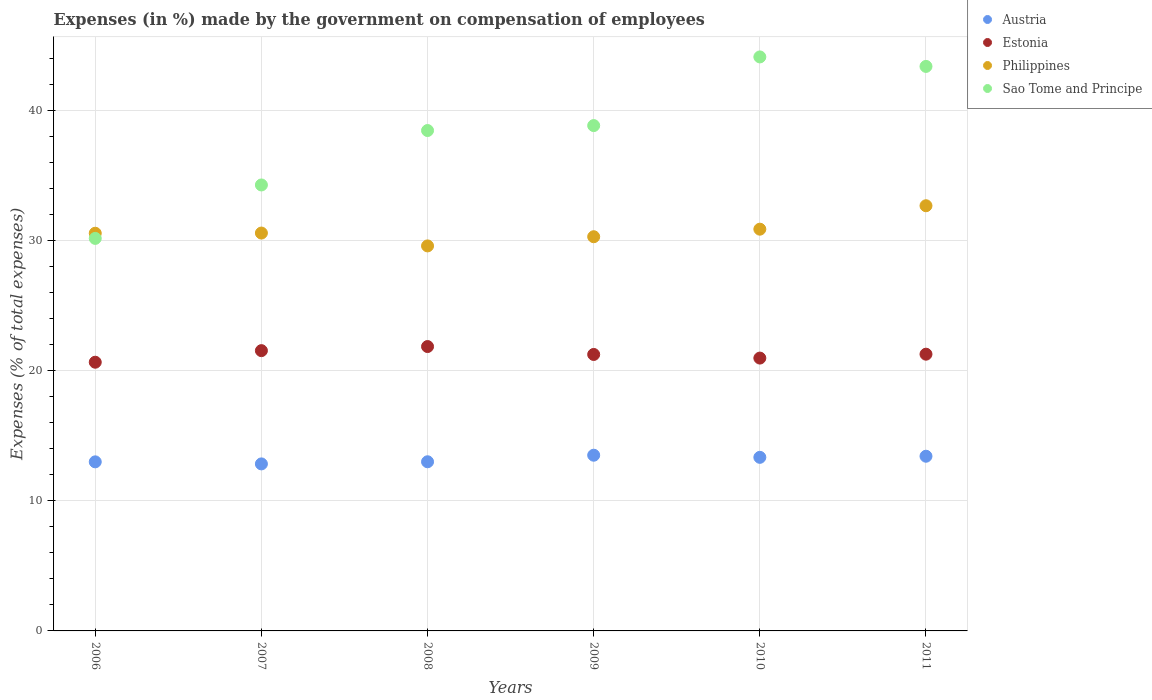How many different coloured dotlines are there?
Offer a terse response. 4. What is the percentage of expenses made by the government on compensation of employees in Philippines in 2006?
Give a very brief answer. 30.58. Across all years, what is the maximum percentage of expenses made by the government on compensation of employees in Austria?
Your answer should be very brief. 13.51. Across all years, what is the minimum percentage of expenses made by the government on compensation of employees in Philippines?
Offer a terse response. 29.6. In which year was the percentage of expenses made by the government on compensation of employees in Estonia minimum?
Your answer should be very brief. 2006. What is the total percentage of expenses made by the government on compensation of employees in Austria in the graph?
Your answer should be very brief. 79.14. What is the difference between the percentage of expenses made by the government on compensation of employees in Sao Tome and Principe in 2006 and that in 2009?
Your response must be concise. -8.67. What is the difference between the percentage of expenses made by the government on compensation of employees in Sao Tome and Principe in 2011 and the percentage of expenses made by the government on compensation of employees in Philippines in 2009?
Keep it short and to the point. 13.1. What is the average percentage of expenses made by the government on compensation of employees in Estonia per year?
Give a very brief answer. 21.27. In the year 2007, what is the difference between the percentage of expenses made by the government on compensation of employees in Austria and percentage of expenses made by the government on compensation of employees in Sao Tome and Principe?
Offer a terse response. -21.45. What is the ratio of the percentage of expenses made by the government on compensation of employees in Sao Tome and Principe in 2007 to that in 2011?
Your answer should be very brief. 0.79. Is the difference between the percentage of expenses made by the government on compensation of employees in Austria in 2009 and 2011 greater than the difference between the percentage of expenses made by the government on compensation of employees in Sao Tome and Principe in 2009 and 2011?
Your response must be concise. Yes. What is the difference between the highest and the second highest percentage of expenses made by the government on compensation of employees in Estonia?
Keep it short and to the point. 0.32. What is the difference between the highest and the lowest percentage of expenses made by the government on compensation of employees in Austria?
Make the answer very short. 0.67. In how many years, is the percentage of expenses made by the government on compensation of employees in Sao Tome and Principe greater than the average percentage of expenses made by the government on compensation of employees in Sao Tome and Principe taken over all years?
Your response must be concise. 4. Is it the case that in every year, the sum of the percentage of expenses made by the government on compensation of employees in Austria and percentage of expenses made by the government on compensation of employees in Philippines  is greater than the sum of percentage of expenses made by the government on compensation of employees in Sao Tome and Principe and percentage of expenses made by the government on compensation of employees in Estonia?
Provide a succinct answer. No. Does the percentage of expenses made by the government on compensation of employees in Sao Tome and Principe monotonically increase over the years?
Provide a short and direct response. No. Is the percentage of expenses made by the government on compensation of employees in Sao Tome and Principe strictly greater than the percentage of expenses made by the government on compensation of employees in Austria over the years?
Your response must be concise. Yes. How many dotlines are there?
Give a very brief answer. 4. How many years are there in the graph?
Provide a short and direct response. 6. Does the graph contain any zero values?
Ensure brevity in your answer.  No. How many legend labels are there?
Give a very brief answer. 4. How are the legend labels stacked?
Give a very brief answer. Vertical. What is the title of the graph?
Your answer should be compact. Expenses (in %) made by the government on compensation of employees. What is the label or title of the X-axis?
Ensure brevity in your answer.  Years. What is the label or title of the Y-axis?
Your answer should be compact. Expenses (% of total expenses). What is the Expenses (% of total expenses) in Austria in 2006?
Give a very brief answer. 13. What is the Expenses (% of total expenses) of Estonia in 2006?
Provide a succinct answer. 20.66. What is the Expenses (% of total expenses) of Philippines in 2006?
Offer a terse response. 30.58. What is the Expenses (% of total expenses) in Sao Tome and Principe in 2006?
Offer a terse response. 30.18. What is the Expenses (% of total expenses) of Austria in 2007?
Ensure brevity in your answer.  12.84. What is the Expenses (% of total expenses) in Estonia in 2007?
Provide a short and direct response. 21.55. What is the Expenses (% of total expenses) of Philippines in 2007?
Keep it short and to the point. 30.59. What is the Expenses (% of total expenses) of Sao Tome and Principe in 2007?
Offer a very short reply. 34.29. What is the Expenses (% of total expenses) of Austria in 2008?
Offer a terse response. 13.01. What is the Expenses (% of total expenses) of Estonia in 2008?
Provide a short and direct response. 21.87. What is the Expenses (% of total expenses) in Philippines in 2008?
Ensure brevity in your answer.  29.6. What is the Expenses (% of total expenses) of Sao Tome and Principe in 2008?
Make the answer very short. 38.48. What is the Expenses (% of total expenses) of Austria in 2009?
Your response must be concise. 13.51. What is the Expenses (% of total expenses) in Estonia in 2009?
Provide a short and direct response. 21.26. What is the Expenses (% of total expenses) in Philippines in 2009?
Ensure brevity in your answer.  30.31. What is the Expenses (% of total expenses) in Sao Tome and Principe in 2009?
Give a very brief answer. 38.86. What is the Expenses (% of total expenses) of Austria in 2010?
Ensure brevity in your answer.  13.35. What is the Expenses (% of total expenses) in Estonia in 2010?
Provide a short and direct response. 20.98. What is the Expenses (% of total expenses) of Philippines in 2010?
Your answer should be very brief. 30.89. What is the Expenses (% of total expenses) in Sao Tome and Principe in 2010?
Provide a succinct answer. 44.14. What is the Expenses (% of total expenses) of Austria in 2011?
Ensure brevity in your answer.  13.43. What is the Expenses (% of total expenses) of Estonia in 2011?
Keep it short and to the point. 21.28. What is the Expenses (% of total expenses) in Philippines in 2011?
Keep it short and to the point. 32.69. What is the Expenses (% of total expenses) of Sao Tome and Principe in 2011?
Give a very brief answer. 43.41. Across all years, what is the maximum Expenses (% of total expenses) in Austria?
Provide a succinct answer. 13.51. Across all years, what is the maximum Expenses (% of total expenses) of Estonia?
Offer a terse response. 21.87. Across all years, what is the maximum Expenses (% of total expenses) of Philippines?
Offer a terse response. 32.69. Across all years, what is the maximum Expenses (% of total expenses) of Sao Tome and Principe?
Offer a very short reply. 44.14. Across all years, what is the minimum Expenses (% of total expenses) in Austria?
Provide a short and direct response. 12.84. Across all years, what is the minimum Expenses (% of total expenses) in Estonia?
Give a very brief answer. 20.66. Across all years, what is the minimum Expenses (% of total expenses) in Philippines?
Ensure brevity in your answer.  29.6. Across all years, what is the minimum Expenses (% of total expenses) in Sao Tome and Principe?
Offer a terse response. 30.18. What is the total Expenses (% of total expenses) in Austria in the graph?
Keep it short and to the point. 79.14. What is the total Expenses (% of total expenses) in Estonia in the graph?
Your answer should be very brief. 127.59. What is the total Expenses (% of total expenses) in Philippines in the graph?
Your response must be concise. 184.67. What is the total Expenses (% of total expenses) in Sao Tome and Principe in the graph?
Provide a short and direct response. 229.35. What is the difference between the Expenses (% of total expenses) in Austria in 2006 and that in 2007?
Your answer should be very brief. 0.16. What is the difference between the Expenses (% of total expenses) of Estonia in 2006 and that in 2007?
Your response must be concise. -0.89. What is the difference between the Expenses (% of total expenses) of Philippines in 2006 and that in 2007?
Your response must be concise. -0.01. What is the difference between the Expenses (% of total expenses) of Sao Tome and Principe in 2006 and that in 2007?
Offer a very short reply. -4.11. What is the difference between the Expenses (% of total expenses) in Austria in 2006 and that in 2008?
Your answer should be very brief. -0.01. What is the difference between the Expenses (% of total expenses) of Estonia in 2006 and that in 2008?
Provide a short and direct response. -1.21. What is the difference between the Expenses (% of total expenses) in Philippines in 2006 and that in 2008?
Your response must be concise. 0.97. What is the difference between the Expenses (% of total expenses) of Sao Tome and Principe in 2006 and that in 2008?
Your answer should be compact. -8.29. What is the difference between the Expenses (% of total expenses) of Austria in 2006 and that in 2009?
Your answer should be compact. -0.51. What is the difference between the Expenses (% of total expenses) of Estonia in 2006 and that in 2009?
Your answer should be compact. -0.6. What is the difference between the Expenses (% of total expenses) of Philippines in 2006 and that in 2009?
Give a very brief answer. 0.27. What is the difference between the Expenses (% of total expenses) in Sao Tome and Principe in 2006 and that in 2009?
Provide a short and direct response. -8.67. What is the difference between the Expenses (% of total expenses) of Austria in 2006 and that in 2010?
Your answer should be very brief. -0.35. What is the difference between the Expenses (% of total expenses) of Estonia in 2006 and that in 2010?
Keep it short and to the point. -0.32. What is the difference between the Expenses (% of total expenses) of Philippines in 2006 and that in 2010?
Offer a very short reply. -0.31. What is the difference between the Expenses (% of total expenses) in Sao Tome and Principe in 2006 and that in 2010?
Offer a terse response. -13.95. What is the difference between the Expenses (% of total expenses) of Austria in 2006 and that in 2011?
Your response must be concise. -0.43. What is the difference between the Expenses (% of total expenses) in Estonia in 2006 and that in 2011?
Provide a short and direct response. -0.62. What is the difference between the Expenses (% of total expenses) in Philippines in 2006 and that in 2011?
Your answer should be compact. -2.12. What is the difference between the Expenses (% of total expenses) in Sao Tome and Principe in 2006 and that in 2011?
Ensure brevity in your answer.  -13.22. What is the difference between the Expenses (% of total expenses) of Austria in 2007 and that in 2008?
Your response must be concise. -0.16. What is the difference between the Expenses (% of total expenses) of Estonia in 2007 and that in 2008?
Your response must be concise. -0.32. What is the difference between the Expenses (% of total expenses) in Philippines in 2007 and that in 2008?
Give a very brief answer. 0.99. What is the difference between the Expenses (% of total expenses) in Sao Tome and Principe in 2007 and that in 2008?
Provide a short and direct response. -4.19. What is the difference between the Expenses (% of total expenses) of Austria in 2007 and that in 2009?
Give a very brief answer. -0.67. What is the difference between the Expenses (% of total expenses) in Estonia in 2007 and that in 2009?
Your answer should be compact. 0.29. What is the difference between the Expenses (% of total expenses) of Philippines in 2007 and that in 2009?
Make the answer very short. 0.28. What is the difference between the Expenses (% of total expenses) of Sao Tome and Principe in 2007 and that in 2009?
Keep it short and to the point. -4.57. What is the difference between the Expenses (% of total expenses) in Austria in 2007 and that in 2010?
Give a very brief answer. -0.5. What is the difference between the Expenses (% of total expenses) of Estonia in 2007 and that in 2010?
Offer a terse response. 0.57. What is the difference between the Expenses (% of total expenses) in Philippines in 2007 and that in 2010?
Offer a terse response. -0.3. What is the difference between the Expenses (% of total expenses) of Sao Tome and Principe in 2007 and that in 2010?
Provide a short and direct response. -9.85. What is the difference between the Expenses (% of total expenses) in Austria in 2007 and that in 2011?
Your answer should be very brief. -0.59. What is the difference between the Expenses (% of total expenses) of Estonia in 2007 and that in 2011?
Make the answer very short. 0.27. What is the difference between the Expenses (% of total expenses) in Philippines in 2007 and that in 2011?
Provide a succinct answer. -2.1. What is the difference between the Expenses (% of total expenses) of Sao Tome and Principe in 2007 and that in 2011?
Provide a short and direct response. -9.12. What is the difference between the Expenses (% of total expenses) in Austria in 2008 and that in 2009?
Give a very brief answer. -0.5. What is the difference between the Expenses (% of total expenses) of Estonia in 2008 and that in 2009?
Provide a short and direct response. 0.61. What is the difference between the Expenses (% of total expenses) in Philippines in 2008 and that in 2009?
Offer a terse response. -0.71. What is the difference between the Expenses (% of total expenses) of Sao Tome and Principe in 2008 and that in 2009?
Your answer should be very brief. -0.38. What is the difference between the Expenses (% of total expenses) of Austria in 2008 and that in 2010?
Provide a succinct answer. -0.34. What is the difference between the Expenses (% of total expenses) of Estonia in 2008 and that in 2010?
Ensure brevity in your answer.  0.89. What is the difference between the Expenses (% of total expenses) of Philippines in 2008 and that in 2010?
Provide a succinct answer. -1.29. What is the difference between the Expenses (% of total expenses) in Sao Tome and Principe in 2008 and that in 2010?
Give a very brief answer. -5.66. What is the difference between the Expenses (% of total expenses) in Austria in 2008 and that in 2011?
Ensure brevity in your answer.  -0.43. What is the difference between the Expenses (% of total expenses) in Estonia in 2008 and that in 2011?
Your response must be concise. 0.59. What is the difference between the Expenses (% of total expenses) in Philippines in 2008 and that in 2011?
Provide a short and direct response. -3.09. What is the difference between the Expenses (% of total expenses) in Sao Tome and Principe in 2008 and that in 2011?
Provide a short and direct response. -4.93. What is the difference between the Expenses (% of total expenses) in Austria in 2009 and that in 2010?
Your answer should be compact. 0.16. What is the difference between the Expenses (% of total expenses) of Estonia in 2009 and that in 2010?
Provide a succinct answer. 0.28. What is the difference between the Expenses (% of total expenses) of Philippines in 2009 and that in 2010?
Offer a terse response. -0.58. What is the difference between the Expenses (% of total expenses) of Sao Tome and Principe in 2009 and that in 2010?
Give a very brief answer. -5.28. What is the difference between the Expenses (% of total expenses) of Austria in 2009 and that in 2011?
Offer a terse response. 0.08. What is the difference between the Expenses (% of total expenses) in Estonia in 2009 and that in 2011?
Give a very brief answer. -0.02. What is the difference between the Expenses (% of total expenses) in Philippines in 2009 and that in 2011?
Offer a terse response. -2.38. What is the difference between the Expenses (% of total expenses) in Sao Tome and Principe in 2009 and that in 2011?
Make the answer very short. -4.55. What is the difference between the Expenses (% of total expenses) in Austria in 2010 and that in 2011?
Your response must be concise. -0.09. What is the difference between the Expenses (% of total expenses) of Estonia in 2010 and that in 2011?
Give a very brief answer. -0.3. What is the difference between the Expenses (% of total expenses) in Philippines in 2010 and that in 2011?
Keep it short and to the point. -1.8. What is the difference between the Expenses (% of total expenses) in Sao Tome and Principe in 2010 and that in 2011?
Your response must be concise. 0.73. What is the difference between the Expenses (% of total expenses) in Austria in 2006 and the Expenses (% of total expenses) in Estonia in 2007?
Make the answer very short. -8.55. What is the difference between the Expenses (% of total expenses) of Austria in 2006 and the Expenses (% of total expenses) of Philippines in 2007?
Ensure brevity in your answer.  -17.59. What is the difference between the Expenses (% of total expenses) in Austria in 2006 and the Expenses (% of total expenses) in Sao Tome and Principe in 2007?
Offer a very short reply. -21.29. What is the difference between the Expenses (% of total expenses) of Estonia in 2006 and the Expenses (% of total expenses) of Philippines in 2007?
Provide a short and direct response. -9.93. What is the difference between the Expenses (% of total expenses) in Estonia in 2006 and the Expenses (% of total expenses) in Sao Tome and Principe in 2007?
Give a very brief answer. -13.63. What is the difference between the Expenses (% of total expenses) in Philippines in 2006 and the Expenses (% of total expenses) in Sao Tome and Principe in 2007?
Provide a succinct answer. -3.71. What is the difference between the Expenses (% of total expenses) in Austria in 2006 and the Expenses (% of total expenses) in Estonia in 2008?
Your response must be concise. -8.87. What is the difference between the Expenses (% of total expenses) in Austria in 2006 and the Expenses (% of total expenses) in Philippines in 2008?
Your answer should be very brief. -16.6. What is the difference between the Expenses (% of total expenses) in Austria in 2006 and the Expenses (% of total expenses) in Sao Tome and Principe in 2008?
Make the answer very short. -25.48. What is the difference between the Expenses (% of total expenses) in Estonia in 2006 and the Expenses (% of total expenses) in Philippines in 2008?
Make the answer very short. -8.94. What is the difference between the Expenses (% of total expenses) of Estonia in 2006 and the Expenses (% of total expenses) of Sao Tome and Principe in 2008?
Your answer should be very brief. -17.82. What is the difference between the Expenses (% of total expenses) in Philippines in 2006 and the Expenses (% of total expenses) in Sao Tome and Principe in 2008?
Your response must be concise. -7.9. What is the difference between the Expenses (% of total expenses) in Austria in 2006 and the Expenses (% of total expenses) in Estonia in 2009?
Your response must be concise. -8.26. What is the difference between the Expenses (% of total expenses) of Austria in 2006 and the Expenses (% of total expenses) of Philippines in 2009?
Make the answer very short. -17.31. What is the difference between the Expenses (% of total expenses) of Austria in 2006 and the Expenses (% of total expenses) of Sao Tome and Principe in 2009?
Your response must be concise. -25.86. What is the difference between the Expenses (% of total expenses) in Estonia in 2006 and the Expenses (% of total expenses) in Philippines in 2009?
Ensure brevity in your answer.  -9.65. What is the difference between the Expenses (% of total expenses) in Estonia in 2006 and the Expenses (% of total expenses) in Sao Tome and Principe in 2009?
Make the answer very short. -18.2. What is the difference between the Expenses (% of total expenses) in Philippines in 2006 and the Expenses (% of total expenses) in Sao Tome and Principe in 2009?
Provide a short and direct response. -8.28. What is the difference between the Expenses (% of total expenses) in Austria in 2006 and the Expenses (% of total expenses) in Estonia in 2010?
Your answer should be very brief. -7.98. What is the difference between the Expenses (% of total expenses) of Austria in 2006 and the Expenses (% of total expenses) of Philippines in 2010?
Ensure brevity in your answer.  -17.89. What is the difference between the Expenses (% of total expenses) of Austria in 2006 and the Expenses (% of total expenses) of Sao Tome and Principe in 2010?
Ensure brevity in your answer.  -31.14. What is the difference between the Expenses (% of total expenses) of Estonia in 2006 and the Expenses (% of total expenses) of Philippines in 2010?
Provide a short and direct response. -10.23. What is the difference between the Expenses (% of total expenses) of Estonia in 2006 and the Expenses (% of total expenses) of Sao Tome and Principe in 2010?
Keep it short and to the point. -23.47. What is the difference between the Expenses (% of total expenses) of Philippines in 2006 and the Expenses (% of total expenses) of Sao Tome and Principe in 2010?
Provide a succinct answer. -13.56. What is the difference between the Expenses (% of total expenses) in Austria in 2006 and the Expenses (% of total expenses) in Estonia in 2011?
Keep it short and to the point. -8.28. What is the difference between the Expenses (% of total expenses) in Austria in 2006 and the Expenses (% of total expenses) in Philippines in 2011?
Make the answer very short. -19.69. What is the difference between the Expenses (% of total expenses) of Austria in 2006 and the Expenses (% of total expenses) of Sao Tome and Principe in 2011?
Your answer should be compact. -30.41. What is the difference between the Expenses (% of total expenses) in Estonia in 2006 and the Expenses (% of total expenses) in Philippines in 2011?
Your answer should be compact. -12.03. What is the difference between the Expenses (% of total expenses) in Estonia in 2006 and the Expenses (% of total expenses) in Sao Tome and Principe in 2011?
Keep it short and to the point. -22.75. What is the difference between the Expenses (% of total expenses) of Philippines in 2006 and the Expenses (% of total expenses) of Sao Tome and Principe in 2011?
Offer a very short reply. -12.83. What is the difference between the Expenses (% of total expenses) in Austria in 2007 and the Expenses (% of total expenses) in Estonia in 2008?
Provide a succinct answer. -9.02. What is the difference between the Expenses (% of total expenses) in Austria in 2007 and the Expenses (% of total expenses) in Philippines in 2008?
Your answer should be compact. -16.76. What is the difference between the Expenses (% of total expenses) of Austria in 2007 and the Expenses (% of total expenses) of Sao Tome and Principe in 2008?
Make the answer very short. -25.63. What is the difference between the Expenses (% of total expenses) in Estonia in 2007 and the Expenses (% of total expenses) in Philippines in 2008?
Make the answer very short. -8.05. What is the difference between the Expenses (% of total expenses) of Estonia in 2007 and the Expenses (% of total expenses) of Sao Tome and Principe in 2008?
Provide a succinct answer. -16.93. What is the difference between the Expenses (% of total expenses) of Philippines in 2007 and the Expenses (% of total expenses) of Sao Tome and Principe in 2008?
Provide a short and direct response. -7.88. What is the difference between the Expenses (% of total expenses) of Austria in 2007 and the Expenses (% of total expenses) of Estonia in 2009?
Provide a short and direct response. -8.42. What is the difference between the Expenses (% of total expenses) of Austria in 2007 and the Expenses (% of total expenses) of Philippines in 2009?
Your answer should be compact. -17.47. What is the difference between the Expenses (% of total expenses) in Austria in 2007 and the Expenses (% of total expenses) in Sao Tome and Principe in 2009?
Provide a succinct answer. -26.01. What is the difference between the Expenses (% of total expenses) in Estonia in 2007 and the Expenses (% of total expenses) in Philippines in 2009?
Give a very brief answer. -8.76. What is the difference between the Expenses (% of total expenses) of Estonia in 2007 and the Expenses (% of total expenses) of Sao Tome and Principe in 2009?
Your answer should be compact. -17.31. What is the difference between the Expenses (% of total expenses) in Philippines in 2007 and the Expenses (% of total expenses) in Sao Tome and Principe in 2009?
Ensure brevity in your answer.  -8.26. What is the difference between the Expenses (% of total expenses) of Austria in 2007 and the Expenses (% of total expenses) of Estonia in 2010?
Ensure brevity in your answer.  -8.14. What is the difference between the Expenses (% of total expenses) of Austria in 2007 and the Expenses (% of total expenses) of Philippines in 2010?
Offer a terse response. -18.05. What is the difference between the Expenses (% of total expenses) of Austria in 2007 and the Expenses (% of total expenses) of Sao Tome and Principe in 2010?
Keep it short and to the point. -31.29. What is the difference between the Expenses (% of total expenses) in Estonia in 2007 and the Expenses (% of total expenses) in Philippines in 2010?
Keep it short and to the point. -9.34. What is the difference between the Expenses (% of total expenses) in Estonia in 2007 and the Expenses (% of total expenses) in Sao Tome and Principe in 2010?
Provide a short and direct response. -22.58. What is the difference between the Expenses (% of total expenses) in Philippines in 2007 and the Expenses (% of total expenses) in Sao Tome and Principe in 2010?
Ensure brevity in your answer.  -13.54. What is the difference between the Expenses (% of total expenses) of Austria in 2007 and the Expenses (% of total expenses) of Estonia in 2011?
Your answer should be very brief. -8.44. What is the difference between the Expenses (% of total expenses) of Austria in 2007 and the Expenses (% of total expenses) of Philippines in 2011?
Your response must be concise. -19.85. What is the difference between the Expenses (% of total expenses) of Austria in 2007 and the Expenses (% of total expenses) of Sao Tome and Principe in 2011?
Offer a very short reply. -30.56. What is the difference between the Expenses (% of total expenses) of Estonia in 2007 and the Expenses (% of total expenses) of Philippines in 2011?
Your response must be concise. -11.14. What is the difference between the Expenses (% of total expenses) of Estonia in 2007 and the Expenses (% of total expenses) of Sao Tome and Principe in 2011?
Your answer should be very brief. -21.86. What is the difference between the Expenses (% of total expenses) in Philippines in 2007 and the Expenses (% of total expenses) in Sao Tome and Principe in 2011?
Offer a terse response. -12.81. What is the difference between the Expenses (% of total expenses) of Austria in 2008 and the Expenses (% of total expenses) of Estonia in 2009?
Give a very brief answer. -8.25. What is the difference between the Expenses (% of total expenses) in Austria in 2008 and the Expenses (% of total expenses) in Philippines in 2009?
Offer a terse response. -17.3. What is the difference between the Expenses (% of total expenses) in Austria in 2008 and the Expenses (% of total expenses) in Sao Tome and Principe in 2009?
Offer a very short reply. -25.85. What is the difference between the Expenses (% of total expenses) in Estonia in 2008 and the Expenses (% of total expenses) in Philippines in 2009?
Your response must be concise. -8.44. What is the difference between the Expenses (% of total expenses) in Estonia in 2008 and the Expenses (% of total expenses) in Sao Tome and Principe in 2009?
Offer a very short reply. -16.99. What is the difference between the Expenses (% of total expenses) in Philippines in 2008 and the Expenses (% of total expenses) in Sao Tome and Principe in 2009?
Your answer should be compact. -9.25. What is the difference between the Expenses (% of total expenses) of Austria in 2008 and the Expenses (% of total expenses) of Estonia in 2010?
Your answer should be compact. -7.97. What is the difference between the Expenses (% of total expenses) of Austria in 2008 and the Expenses (% of total expenses) of Philippines in 2010?
Keep it short and to the point. -17.88. What is the difference between the Expenses (% of total expenses) of Austria in 2008 and the Expenses (% of total expenses) of Sao Tome and Principe in 2010?
Give a very brief answer. -31.13. What is the difference between the Expenses (% of total expenses) in Estonia in 2008 and the Expenses (% of total expenses) in Philippines in 2010?
Offer a terse response. -9.02. What is the difference between the Expenses (% of total expenses) in Estonia in 2008 and the Expenses (% of total expenses) in Sao Tome and Principe in 2010?
Your answer should be very brief. -22.27. What is the difference between the Expenses (% of total expenses) of Philippines in 2008 and the Expenses (% of total expenses) of Sao Tome and Principe in 2010?
Ensure brevity in your answer.  -14.53. What is the difference between the Expenses (% of total expenses) of Austria in 2008 and the Expenses (% of total expenses) of Estonia in 2011?
Your response must be concise. -8.27. What is the difference between the Expenses (% of total expenses) in Austria in 2008 and the Expenses (% of total expenses) in Philippines in 2011?
Make the answer very short. -19.69. What is the difference between the Expenses (% of total expenses) in Austria in 2008 and the Expenses (% of total expenses) in Sao Tome and Principe in 2011?
Your response must be concise. -30.4. What is the difference between the Expenses (% of total expenses) in Estonia in 2008 and the Expenses (% of total expenses) in Philippines in 2011?
Provide a succinct answer. -10.83. What is the difference between the Expenses (% of total expenses) in Estonia in 2008 and the Expenses (% of total expenses) in Sao Tome and Principe in 2011?
Your response must be concise. -21.54. What is the difference between the Expenses (% of total expenses) in Philippines in 2008 and the Expenses (% of total expenses) in Sao Tome and Principe in 2011?
Keep it short and to the point. -13.8. What is the difference between the Expenses (% of total expenses) of Austria in 2009 and the Expenses (% of total expenses) of Estonia in 2010?
Offer a very short reply. -7.47. What is the difference between the Expenses (% of total expenses) in Austria in 2009 and the Expenses (% of total expenses) in Philippines in 2010?
Offer a very short reply. -17.38. What is the difference between the Expenses (% of total expenses) of Austria in 2009 and the Expenses (% of total expenses) of Sao Tome and Principe in 2010?
Provide a short and direct response. -30.62. What is the difference between the Expenses (% of total expenses) in Estonia in 2009 and the Expenses (% of total expenses) in Philippines in 2010?
Your answer should be compact. -9.63. What is the difference between the Expenses (% of total expenses) of Estonia in 2009 and the Expenses (% of total expenses) of Sao Tome and Principe in 2010?
Offer a very short reply. -22.88. What is the difference between the Expenses (% of total expenses) of Philippines in 2009 and the Expenses (% of total expenses) of Sao Tome and Principe in 2010?
Keep it short and to the point. -13.83. What is the difference between the Expenses (% of total expenses) of Austria in 2009 and the Expenses (% of total expenses) of Estonia in 2011?
Ensure brevity in your answer.  -7.77. What is the difference between the Expenses (% of total expenses) of Austria in 2009 and the Expenses (% of total expenses) of Philippines in 2011?
Give a very brief answer. -19.18. What is the difference between the Expenses (% of total expenses) in Austria in 2009 and the Expenses (% of total expenses) in Sao Tome and Principe in 2011?
Offer a very short reply. -29.9. What is the difference between the Expenses (% of total expenses) in Estonia in 2009 and the Expenses (% of total expenses) in Philippines in 2011?
Make the answer very short. -11.44. What is the difference between the Expenses (% of total expenses) of Estonia in 2009 and the Expenses (% of total expenses) of Sao Tome and Principe in 2011?
Your response must be concise. -22.15. What is the difference between the Expenses (% of total expenses) in Philippines in 2009 and the Expenses (% of total expenses) in Sao Tome and Principe in 2011?
Provide a short and direct response. -13.1. What is the difference between the Expenses (% of total expenses) in Austria in 2010 and the Expenses (% of total expenses) in Estonia in 2011?
Your answer should be compact. -7.93. What is the difference between the Expenses (% of total expenses) of Austria in 2010 and the Expenses (% of total expenses) of Philippines in 2011?
Your response must be concise. -19.35. What is the difference between the Expenses (% of total expenses) of Austria in 2010 and the Expenses (% of total expenses) of Sao Tome and Principe in 2011?
Offer a very short reply. -30.06. What is the difference between the Expenses (% of total expenses) of Estonia in 2010 and the Expenses (% of total expenses) of Philippines in 2011?
Your answer should be very brief. -11.71. What is the difference between the Expenses (% of total expenses) in Estonia in 2010 and the Expenses (% of total expenses) in Sao Tome and Principe in 2011?
Provide a succinct answer. -22.43. What is the difference between the Expenses (% of total expenses) of Philippines in 2010 and the Expenses (% of total expenses) of Sao Tome and Principe in 2011?
Ensure brevity in your answer.  -12.52. What is the average Expenses (% of total expenses) in Austria per year?
Your answer should be very brief. 13.19. What is the average Expenses (% of total expenses) of Estonia per year?
Give a very brief answer. 21.27. What is the average Expenses (% of total expenses) in Philippines per year?
Give a very brief answer. 30.78. What is the average Expenses (% of total expenses) of Sao Tome and Principe per year?
Ensure brevity in your answer.  38.22. In the year 2006, what is the difference between the Expenses (% of total expenses) of Austria and Expenses (% of total expenses) of Estonia?
Offer a very short reply. -7.66. In the year 2006, what is the difference between the Expenses (% of total expenses) in Austria and Expenses (% of total expenses) in Philippines?
Offer a terse response. -17.58. In the year 2006, what is the difference between the Expenses (% of total expenses) of Austria and Expenses (% of total expenses) of Sao Tome and Principe?
Provide a short and direct response. -17.18. In the year 2006, what is the difference between the Expenses (% of total expenses) of Estonia and Expenses (% of total expenses) of Philippines?
Ensure brevity in your answer.  -9.92. In the year 2006, what is the difference between the Expenses (% of total expenses) of Estonia and Expenses (% of total expenses) of Sao Tome and Principe?
Ensure brevity in your answer.  -9.52. In the year 2006, what is the difference between the Expenses (% of total expenses) of Philippines and Expenses (% of total expenses) of Sao Tome and Principe?
Offer a terse response. 0.4. In the year 2007, what is the difference between the Expenses (% of total expenses) of Austria and Expenses (% of total expenses) of Estonia?
Ensure brevity in your answer.  -8.71. In the year 2007, what is the difference between the Expenses (% of total expenses) in Austria and Expenses (% of total expenses) in Philippines?
Your answer should be compact. -17.75. In the year 2007, what is the difference between the Expenses (% of total expenses) in Austria and Expenses (% of total expenses) in Sao Tome and Principe?
Provide a succinct answer. -21.45. In the year 2007, what is the difference between the Expenses (% of total expenses) in Estonia and Expenses (% of total expenses) in Philippines?
Give a very brief answer. -9.04. In the year 2007, what is the difference between the Expenses (% of total expenses) in Estonia and Expenses (% of total expenses) in Sao Tome and Principe?
Offer a very short reply. -12.74. In the year 2007, what is the difference between the Expenses (% of total expenses) of Philippines and Expenses (% of total expenses) of Sao Tome and Principe?
Your response must be concise. -3.7. In the year 2008, what is the difference between the Expenses (% of total expenses) of Austria and Expenses (% of total expenses) of Estonia?
Provide a short and direct response. -8.86. In the year 2008, what is the difference between the Expenses (% of total expenses) in Austria and Expenses (% of total expenses) in Philippines?
Your answer should be very brief. -16.6. In the year 2008, what is the difference between the Expenses (% of total expenses) of Austria and Expenses (% of total expenses) of Sao Tome and Principe?
Make the answer very short. -25.47. In the year 2008, what is the difference between the Expenses (% of total expenses) in Estonia and Expenses (% of total expenses) in Philippines?
Keep it short and to the point. -7.74. In the year 2008, what is the difference between the Expenses (% of total expenses) in Estonia and Expenses (% of total expenses) in Sao Tome and Principe?
Give a very brief answer. -16.61. In the year 2008, what is the difference between the Expenses (% of total expenses) of Philippines and Expenses (% of total expenses) of Sao Tome and Principe?
Your answer should be very brief. -8.87. In the year 2009, what is the difference between the Expenses (% of total expenses) in Austria and Expenses (% of total expenses) in Estonia?
Provide a succinct answer. -7.75. In the year 2009, what is the difference between the Expenses (% of total expenses) in Austria and Expenses (% of total expenses) in Philippines?
Keep it short and to the point. -16.8. In the year 2009, what is the difference between the Expenses (% of total expenses) of Austria and Expenses (% of total expenses) of Sao Tome and Principe?
Your answer should be very brief. -25.35. In the year 2009, what is the difference between the Expenses (% of total expenses) of Estonia and Expenses (% of total expenses) of Philippines?
Provide a succinct answer. -9.05. In the year 2009, what is the difference between the Expenses (% of total expenses) in Estonia and Expenses (% of total expenses) in Sao Tome and Principe?
Ensure brevity in your answer.  -17.6. In the year 2009, what is the difference between the Expenses (% of total expenses) of Philippines and Expenses (% of total expenses) of Sao Tome and Principe?
Make the answer very short. -8.55. In the year 2010, what is the difference between the Expenses (% of total expenses) in Austria and Expenses (% of total expenses) in Estonia?
Give a very brief answer. -7.63. In the year 2010, what is the difference between the Expenses (% of total expenses) of Austria and Expenses (% of total expenses) of Philippines?
Provide a short and direct response. -17.54. In the year 2010, what is the difference between the Expenses (% of total expenses) in Austria and Expenses (% of total expenses) in Sao Tome and Principe?
Your response must be concise. -30.79. In the year 2010, what is the difference between the Expenses (% of total expenses) in Estonia and Expenses (% of total expenses) in Philippines?
Ensure brevity in your answer.  -9.91. In the year 2010, what is the difference between the Expenses (% of total expenses) of Estonia and Expenses (% of total expenses) of Sao Tome and Principe?
Offer a very short reply. -23.16. In the year 2010, what is the difference between the Expenses (% of total expenses) in Philippines and Expenses (% of total expenses) in Sao Tome and Principe?
Offer a terse response. -13.24. In the year 2011, what is the difference between the Expenses (% of total expenses) of Austria and Expenses (% of total expenses) of Estonia?
Your answer should be compact. -7.85. In the year 2011, what is the difference between the Expenses (% of total expenses) in Austria and Expenses (% of total expenses) in Philippines?
Ensure brevity in your answer.  -19.26. In the year 2011, what is the difference between the Expenses (% of total expenses) of Austria and Expenses (% of total expenses) of Sao Tome and Principe?
Your answer should be very brief. -29.97. In the year 2011, what is the difference between the Expenses (% of total expenses) of Estonia and Expenses (% of total expenses) of Philippines?
Give a very brief answer. -11.41. In the year 2011, what is the difference between the Expenses (% of total expenses) of Estonia and Expenses (% of total expenses) of Sao Tome and Principe?
Keep it short and to the point. -22.13. In the year 2011, what is the difference between the Expenses (% of total expenses) in Philippines and Expenses (% of total expenses) in Sao Tome and Principe?
Provide a short and direct response. -10.71. What is the ratio of the Expenses (% of total expenses) in Austria in 2006 to that in 2007?
Your answer should be very brief. 1.01. What is the ratio of the Expenses (% of total expenses) in Estonia in 2006 to that in 2007?
Keep it short and to the point. 0.96. What is the ratio of the Expenses (% of total expenses) in Sao Tome and Principe in 2006 to that in 2007?
Your response must be concise. 0.88. What is the ratio of the Expenses (% of total expenses) of Estonia in 2006 to that in 2008?
Your answer should be compact. 0.94. What is the ratio of the Expenses (% of total expenses) in Philippines in 2006 to that in 2008?
Provide a short and direct response. 1.03. What is the ratio of the Expenses (% of total expenses) in Sao Tome and Principe in 2006 to that in 2008?
Provide a succinct answer. 0.78. What is the ratio of the Expenses (% of total expenses) of Austria in 2006 to that in 2009?
Offer a terse response. 0.96. What is the ratio of the Expenses (% of total expenses) in Estonia in 2006 to that in 2009?
Give a very brief answer. 0.97. What is the ratio of the Expenses (% of total expenses) in Philippines in 2006 to that in 2009?
Your response must be concise. 1.01. What is the ratio of the Expenses (% of total expenses) of Sao Tome and Principe in 2006 to that in 2009?
Your answer should be very brief. 0.78. What is the ratio of the Expenses (% of total expenses) of Austria in 2006 to that in 2010?
Give a very brief answer. 0.97. What is the ratio of the Expenses (% of total expenses) of Estonia in 2006 to that in 2010?
Offer a very short reply. 0.98. What is the ratio of the Expenses (% of total expenses) in Philippines in 2006 to that in 2010?
Keep it short and to the point. 0.99. What is the ratio of the Expenses (% of total expenses) in Sao Tome and Principe in 2006 to that in 2010?
Offer a very short reply. 0.68. What is the ratio of the Expenses (% of total expenses) in Austria in 2006 to that in 2011?
Offer a terse response. 0.97. What is the ratio of the Expenses (% of total expenses) in Philippines in 2006 to that in 2011?
Your answer should be very brief. 0.94. What is the ratio of the Expenses (% of total expenses) in Sao Tome and Principe in 2006 to that in 2011?
Offer a very short reply. 0.7. What is the ratio of the Expenses (% of total expenses) of Austria in 2007 to that in 2008?
Provide a short and direct response. 0.99. What is the ratio of the Expenses (% of total expenses) of Estonia in 2007 to that in 2008?
Ensure brevity in your answer.  0.99. What is the ratio of the Expenses (% of total expenses) in Philippines in 2007 to that in 2008?
Your answer should be very brief. 1.03. What is the ratio of the Expenses (% of total expenses) in Sao Tome and Principe in 2007 to that in 2008?
Your answer should be compact. 0.89. What is the ratio of the Expenses (% of total expenses) of Austria in 2007 to that in 2009?
Keep it short and to the point. 0.95. What is the ratio of the Expenses (% of total expenses) in Estonia in 2007 to that in 2009?
Your response must be concise. 1.01. What is the ratio of the Expenses (% of total expenses) of Philippines in 2007 to that in 2009?
Offer a very short reply. 1.01. What is the ratio of the Expenses (% of total expenses) in Sao Tome and Principe in 2007 to that in 2009?
Offer a terse response. 0.88. What is the ratio of the Expenses (% of total expenses) of Austria in 2007 to that in 2010?
Keep it short and to the point. 0.96. What is the ratio of the Expenses (% of total expenses) in Estonia in 2007 to that in 2010?
Keep it short and to the point. 1.03. What is the ratio of the Expenses (% of total expenses) of Philippines in 2007 to that in 2010?
Your response must be concise. 0.99. What is the ratio of the Expenses (% of total expenses) in Sao Tome and Principe in 2007 to that in 2010?
Provide a succinct answer. 0.78. What is the ratio of the Expenses (% of total expenses) in Austria in 2007 to that in 2011?
Provide a succinct answer. 0.96. What is the ratio of the Expenses (% of total expenses) in Estonia in 2007 to that in 2011?
Keep it short and to the point. 1.01. What is the ratio of the Expenses (% of total expenses) of Philippines in 2007 to that in 2011?
Offer a terse response. 0.94. What is the ratio of the Expenses (% of total expenses) in Sao Tome and Principe in 2007 to that in 2011?
Offer a very short reply. 0.79. What is the ratio of the Expenses (% of total expenses) in Austria in 2008 to that in 2009?
Give a very brief answer. 0.96. What is the ratio of the Expenses (% of total expenses) in Estonia in 2008 to that in 2009?
Your answer should be compact. 1.03. What is the ratio of the Expenses (% of total expenses) of Philippines in 2008 to that in 2009?
Your answer should be very brief. 0.98. What is the ratio of the Expenses (% of total expenses) of Sao Tome and Principe in 2008 to that in 2009?
Your answer should be very brief. 0.99. What is the ratio of the Expenses (% of total expenses) of Austria in 2008 to that in 2010?
Make the answer very short. 0.97. What is the ratio of the Expenses (% of total expenses) in Estonia in 2008 to that in 2010?
Offer a very short reply. 1.04. What is the ratio of the Expenses (% of total expenses) of Philippines in 2008 to that in 2010?
Provide a short and direct response. 0.96. What is the ratio of the Expenses (% of total expenses) in Sao Tome and Principe in 2008 to that in 2010?
Keep it short and to the point. 0.87. What is the ratio of the Expenses (% of total expenses) of Austria in 2008 to that in 2011?
Your answer should be very brief. 0.97. What is the ratio of the Expenses (% of total expenses) of Estonia in 2008 to that in 2011?
Your response must be concise. 1.03. What is the ratio of the Expenses (% of total expenses) in Philippines in 2008 to that in 2011?
Make the answer very short. 0.91. What is the ratio of the Expenses (% of total expenses) of Sao Tome and Principe in 2008 to that in 2011?
Offer a terse response. 0.89. What is the ratio of the Expenses (% of total expenses) in Austria in 2009 to that in 2010?
Your answer should be compact. 1.01. What is the ratio of the Expenses (% of total expenses) in Estonia in 2009 to that in 2010?
Offer a terse response. 1.01. What is the ratio of the Expenses (% of total expenses) of Philippines in 2009 to that in 2010?
Provide a short and direct response. 0.98. What is the ratio of the Expenses (% of total expenses) of Sao Tome and Principe in 2009 to that in 2010?
Give a very brief answer. 0.88. What is the ratio of the Expenses (% of total expenses) in Austria in 2009 to that in 2011?
Keep it short and to the point. 1.01. What is the ratio of the Expenses (% of total expenses) of Estonia in 2009 to that in 2011?
Provide a succinct answer. 1. What is the ratio of the Expenses (% of total expenses) in Philippines in 2009 to that in 2011?
Your answer should be compact. 0.93. What is the ratio of the Expenses (% of total expenses) of Sao Tome and Principe in 2009 to that in 2011?
Offer a very short reply. 0.9. What is the ratio of the Expenses (% of total expenses) in Austria in 2010 to that in 2011?
Give a very brief answer. 0.99. What is the ratio of the Expenses (% of total expenses) of Estonia in 2010 to that in 2011?
Your answer should be very brief. 0.99. What is the ratio of the Expenses (% of total expenses) in Philippines in 2010 to that in 2011?
Give a very brief answer. 0.94. What is the ratio of the Expenses (% of total expenses) of Sao Tome and Principe in 2010 to that in 2011?
Ensure brevity in your answer.  1.02. What is the difference between the highest and the second highest Expenses (% of total expenses) of Austria?
Your answer should be very brief. 0.08. What is the difference between the highest and the second highest Expenses (% of total expenses) of Estonia?
Make the answer very short. 0.32. What is the difference between the highest and the second highest Expenses (% of total expenses) of Philippines?
Your response must be concise. 1.8. What is the difference between the highest and the second highest Expenses (% of total expenses) in Sao Tome and Principe?
Your response must be concise. 0.73. What is the difference between the highest and the lowest Expenses (% of total expenses) of Austria?
Ensure brevity in your answer.  0.67. What is the difference between the highest and the lowest Expenses (% of total expenses) of Estonia?
Provide a short and direct response. 1.21. What is the difference between the highest and the lowest Expenses (% of total expenses) in Philippines?
Your answer should be very brief. 3.09. What is the difference between the highest and the lowest Expenses (% of total expenses) in Sao Tome and Principe?
Ensure brevity in your answer.  13.95. 